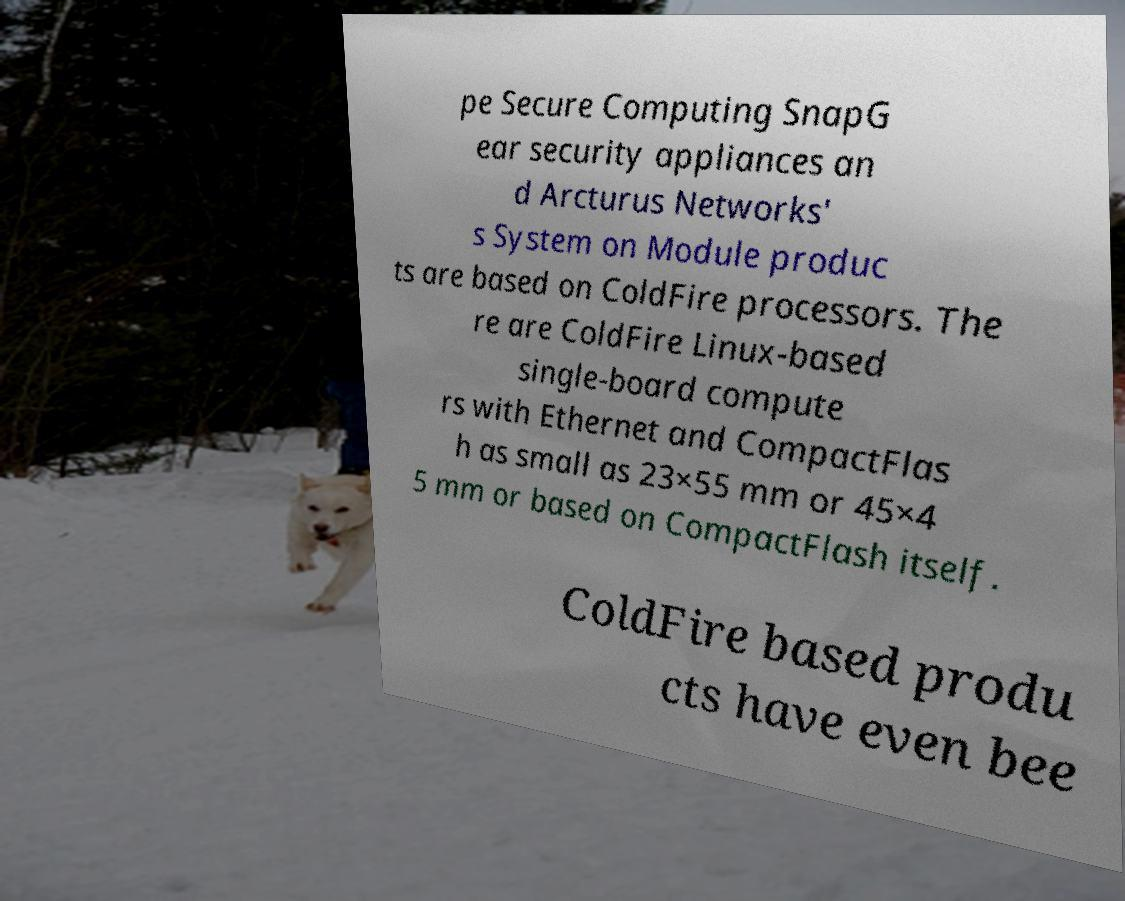What messages or text are displayed in this image? I need them in a readable, typed format. pe Secure Computing SnapG ear security appliances an d Arcturus Networks' s System on Module produc ts are based on ColdFire processors. The re are ColdFire Linux-based single-board compute rs with Ethernet and CompactFlas h as small as 23×55 mm or 45×4 5 mm or based on CompactFlash itself. ColdFire based produ cts have even bee 